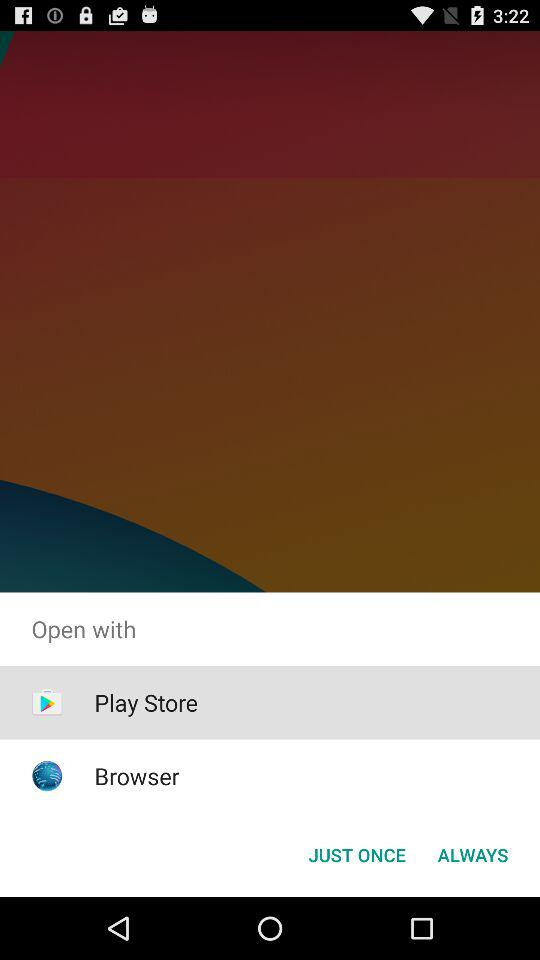With which application can we open it? You can open it with "Play Store" and "Browser". 